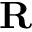<formula> <loc_0><loc_0><loc_500><loc_500>R</formula> 